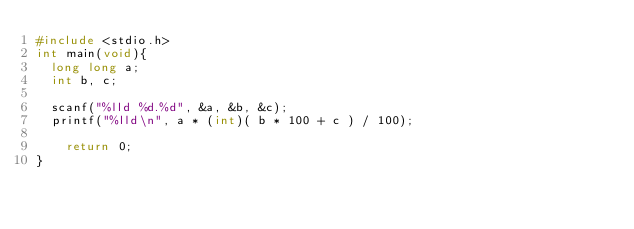<code> <loc_0><loc_0><loc_500><loc_500><_C_>#include <stdio.h>
int main(void){
	long long a;
	int b, c;
 
	scanf("%lld %d.%d", &a, &b, &c);
	printf("%lld\n", a * (int)( b * 100 + c ) / 100);

    return 0;
}</code> 